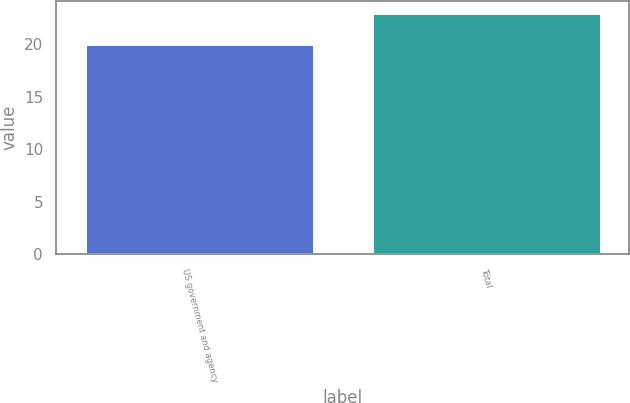<chart> <loc_0><loc_0><loc_500><loc_500><bar_chart><fcel>US government and agency<fcel>Total<nl><fcel>20<fcel>23<nl></chart> 